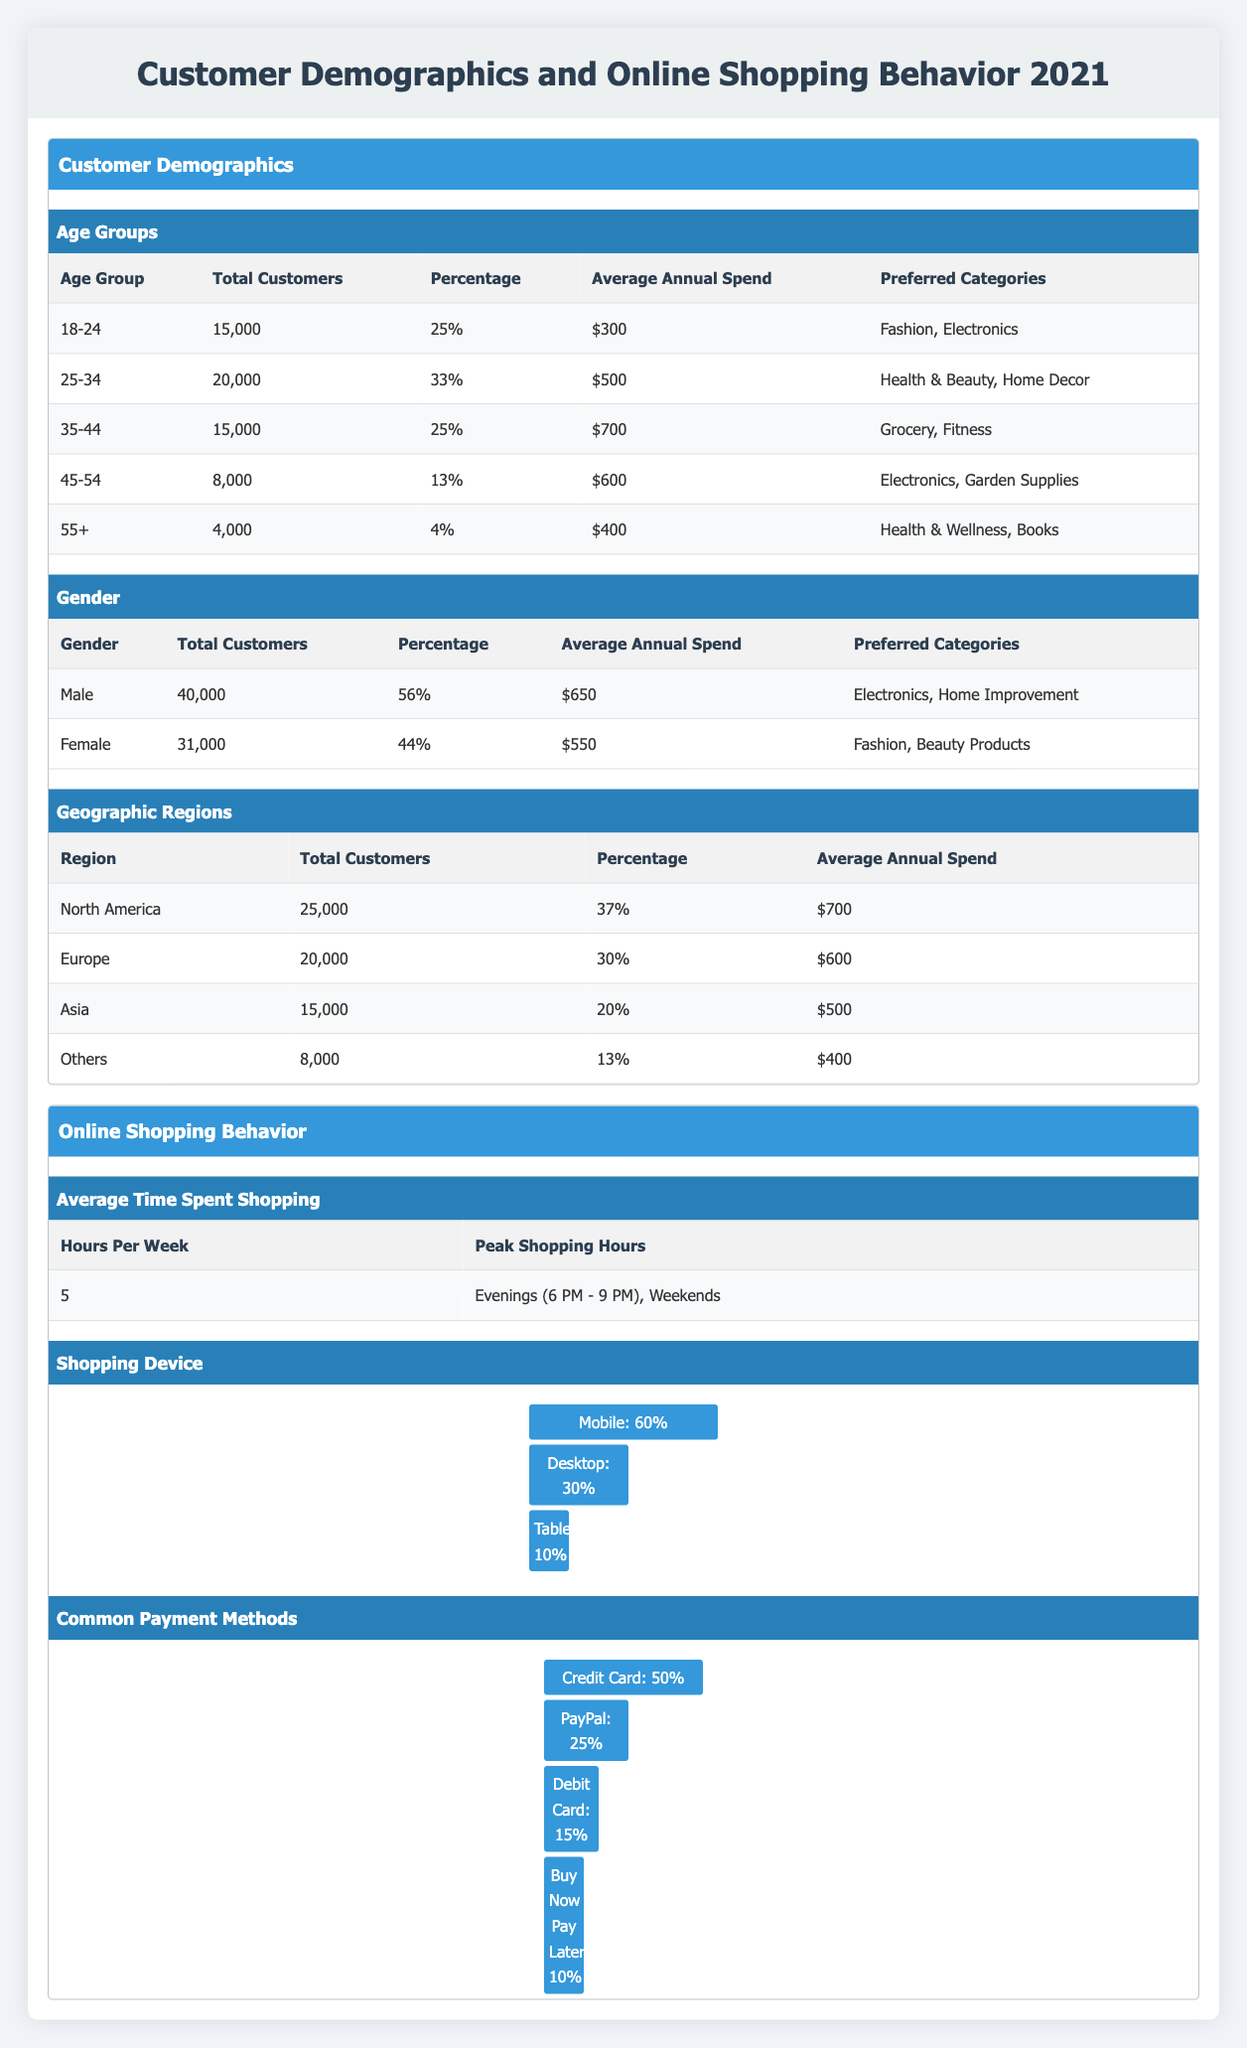What is the total number of customers in the age group 25-34? According to the table under the Age Groups section, the total number of customers in the 25-34 age group is specified as 20,000.
Answer: 20,000 What percentage of total customers are females? In the Gender section of the table, the percentage of female customers is listed as 44%.
Answer: 44% Which age group has the highest average annual spend? The average annual spend for each age group is compared: 18-24 ($300), 25-34 ($500), 35-44 ($700), 45-54 ($600), and 55+ ($400). The highest average annual spend is from the 35-44 age group at $700.
Answer: 35-44 What is the total average annual spend for customers in North America and Europe? The average annual spend for North America is $700 and for Europe is $600. Adding these together gives $700 + $600 = $1,300, which is the total average annual spend for customers in these regions.
Answer: $1,300 Is the average annual spend for males higher than for females? The average annual spend for males is $650, while for females it is $550. Since $650 is greater than $550, the statement is true.
Answer: Yes What is the percentage of customers who shop using mobile devices? In the Shopping Device section, it is stated that 60% of customers shop using mobile devices.
Answer: 60% If the total number of customers is 71,000, what percentage represents customers aged 55 and above? The total for the 55+ age group is 4,000. To find the percentage, the calculation is (4,000 / 71,000) * 100, which equals approximately 5.63%.
Answer: 5.63% What is the most preferred shopping device according to the data? The Shopping Device section indicates that 60% of customers use mobile devices, which is more than the percentages for desktop (30%) and tablet (10%). Therefore, mobile is the most preferred shopping device.
Answer: Mobile What is the average number of hours per week spent shopping if customers predominantly shop during evenings and weekends? The table mentions that customers spend an average of 5 hours per week shopping. This is the direct answer, regardless of the peak shopping times.
Answer: 5 hours 